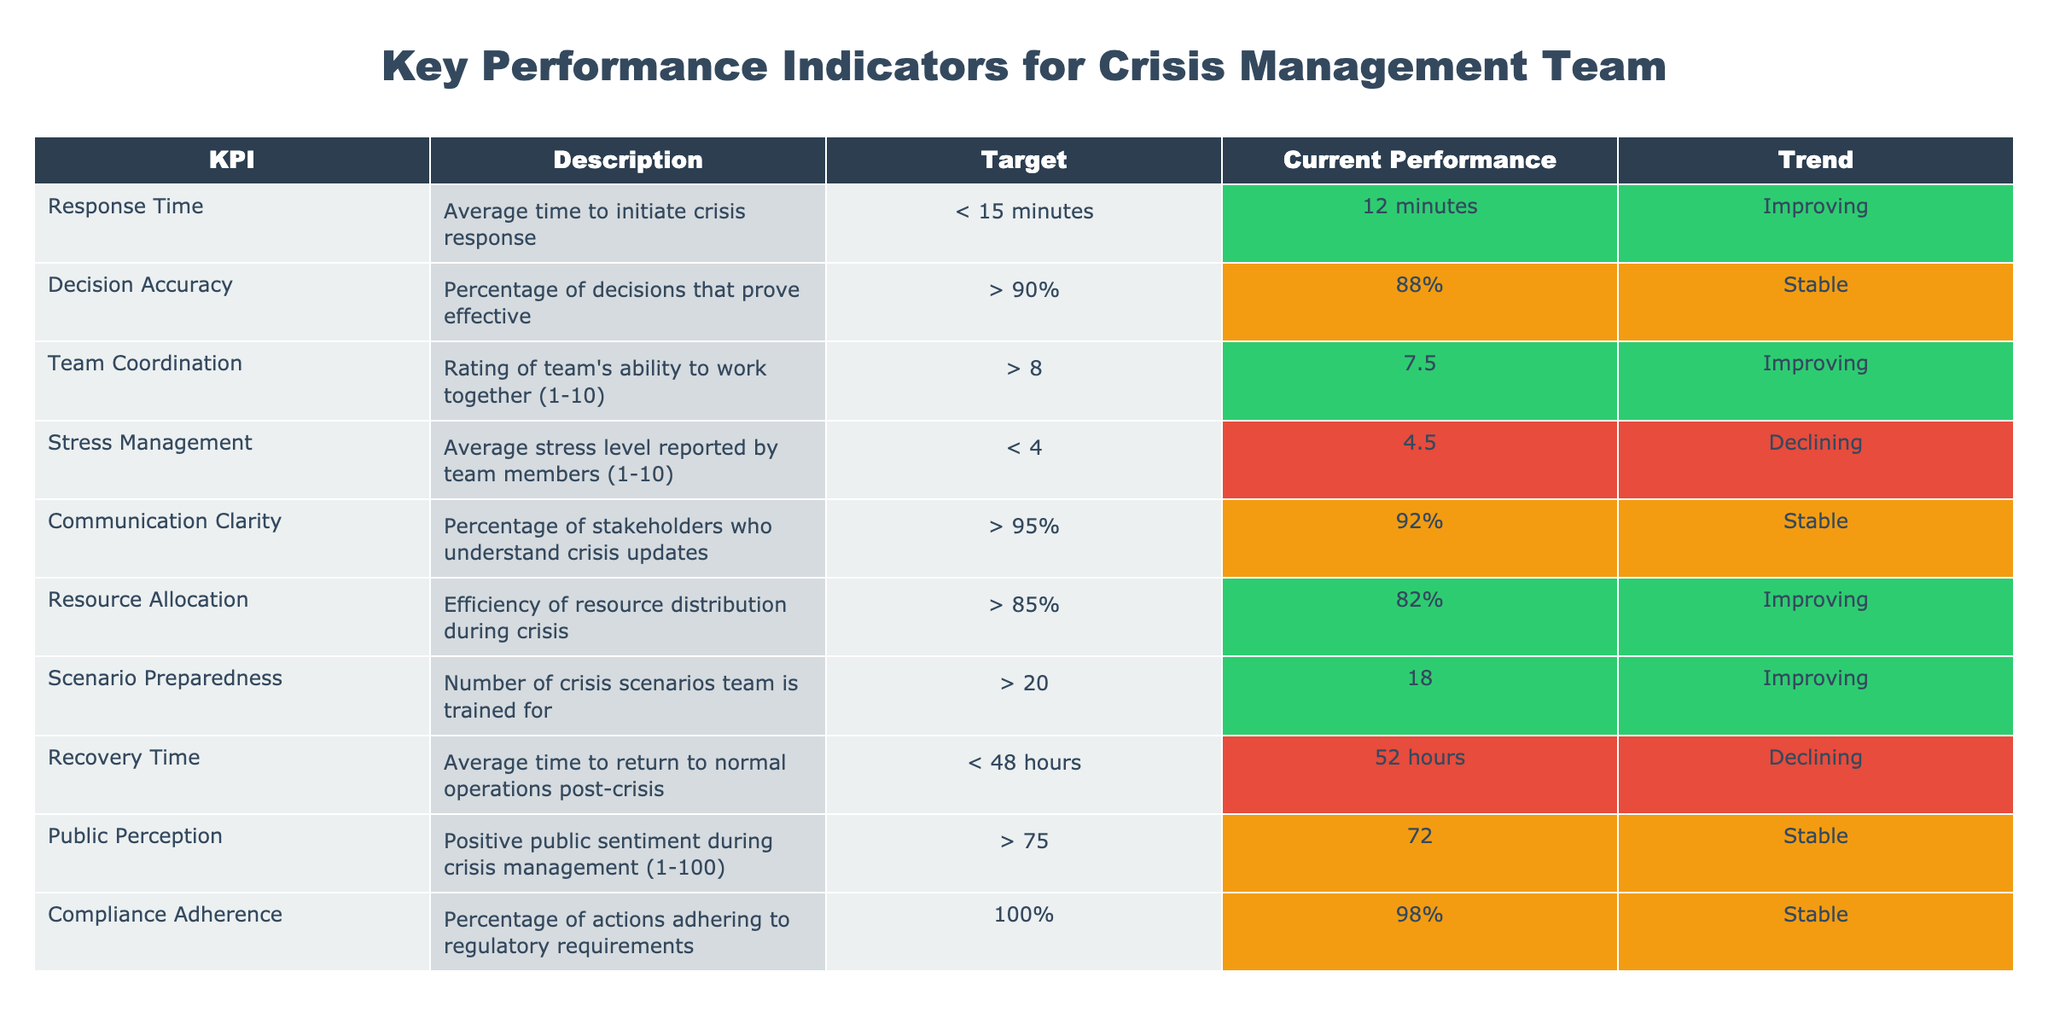What is the current performance of the Response Time KPI? The table states the current performance of Response Time is 12 minutes.
Answer: 12 minutes What is the target for Decision Accuracy? The target for Decision Accuracy is greater than 90%.
Answer: > 90% Is the Team Coordination KPI currently meeting its target? The target for Team Coordination is greater than 8, while the current performance is 7.5, indicating it is not meeting the target.
Answer: No What is the average stress level reported by team members? The table shows the average stress level reported by team members is 4.5.
Answer: 4.5 Which KPI shows a stable trend? The KPIs with a stable trend are Decision Accuracy, Communication Clarity, and Compliance Adherence.
Answer: Decision Accuracy, Communication Clarity, Compliance Adherence How many crisis scenarios is the team currently trained for? The table indicates the team is currently trained for 18 crisis scenarios.
Answer: 18 What is the difference between the target Recovery Time and the current Recovery Time? The target Recovery Time is less than 48 hours, while the current Recovery Time is 52 hours, making the difference 52 - 48 = 4 hours (though the target is not a specific value, it indicates a deficit).
Answer: 4 hours Which KPI is declining and what is its current performance? The KPI that is declining is Stress Management, with a current performance of 4.5.
Answer: Stress Management, 4.5 What is the overall trend for Resource Allocation? The trend for Resource Allocation is improving as per the table.
Answer: Improving If the Crisis Management Team needs to improve Decision Accuracy, by how much must they increase the current performance to meet the target? The current Decision Accuracy is 88%, and the target is greater than 90%, so they need to increase it by at least 2%.
Answer: 2% 